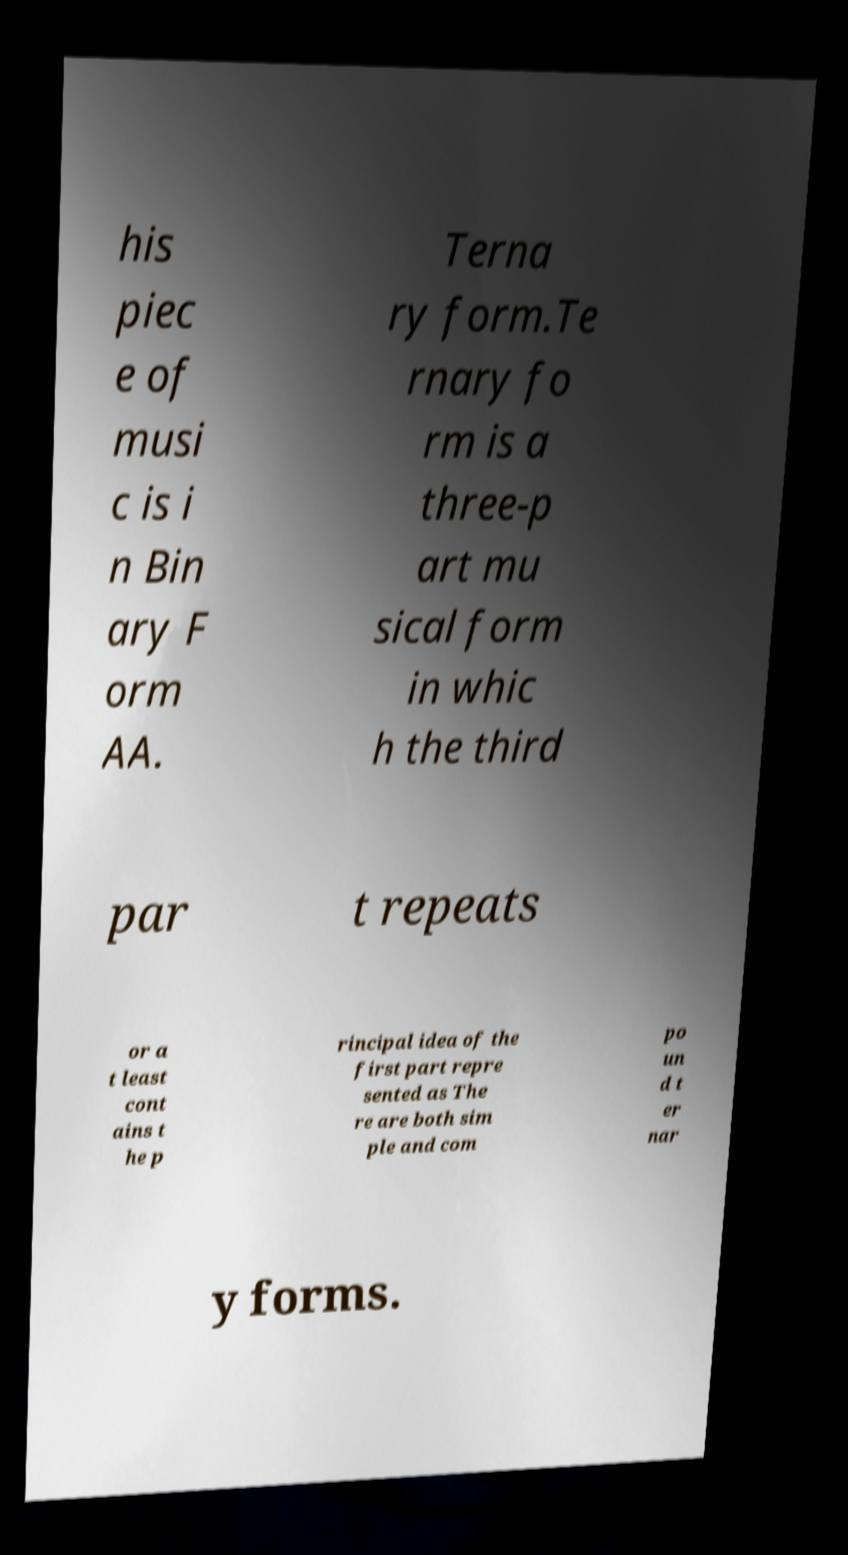Please identify and transcribe the text found in this image. his piec e of musi c is i n Bin ary F orm AA. Terna ry form.Te rnary fo rm is a three-p art mu sical form in whic h the third par t repeats or a t least cont ains t he p rincipal idea of the first part repre sented as The re are both sim ple and com po un d t er nar y forms. 